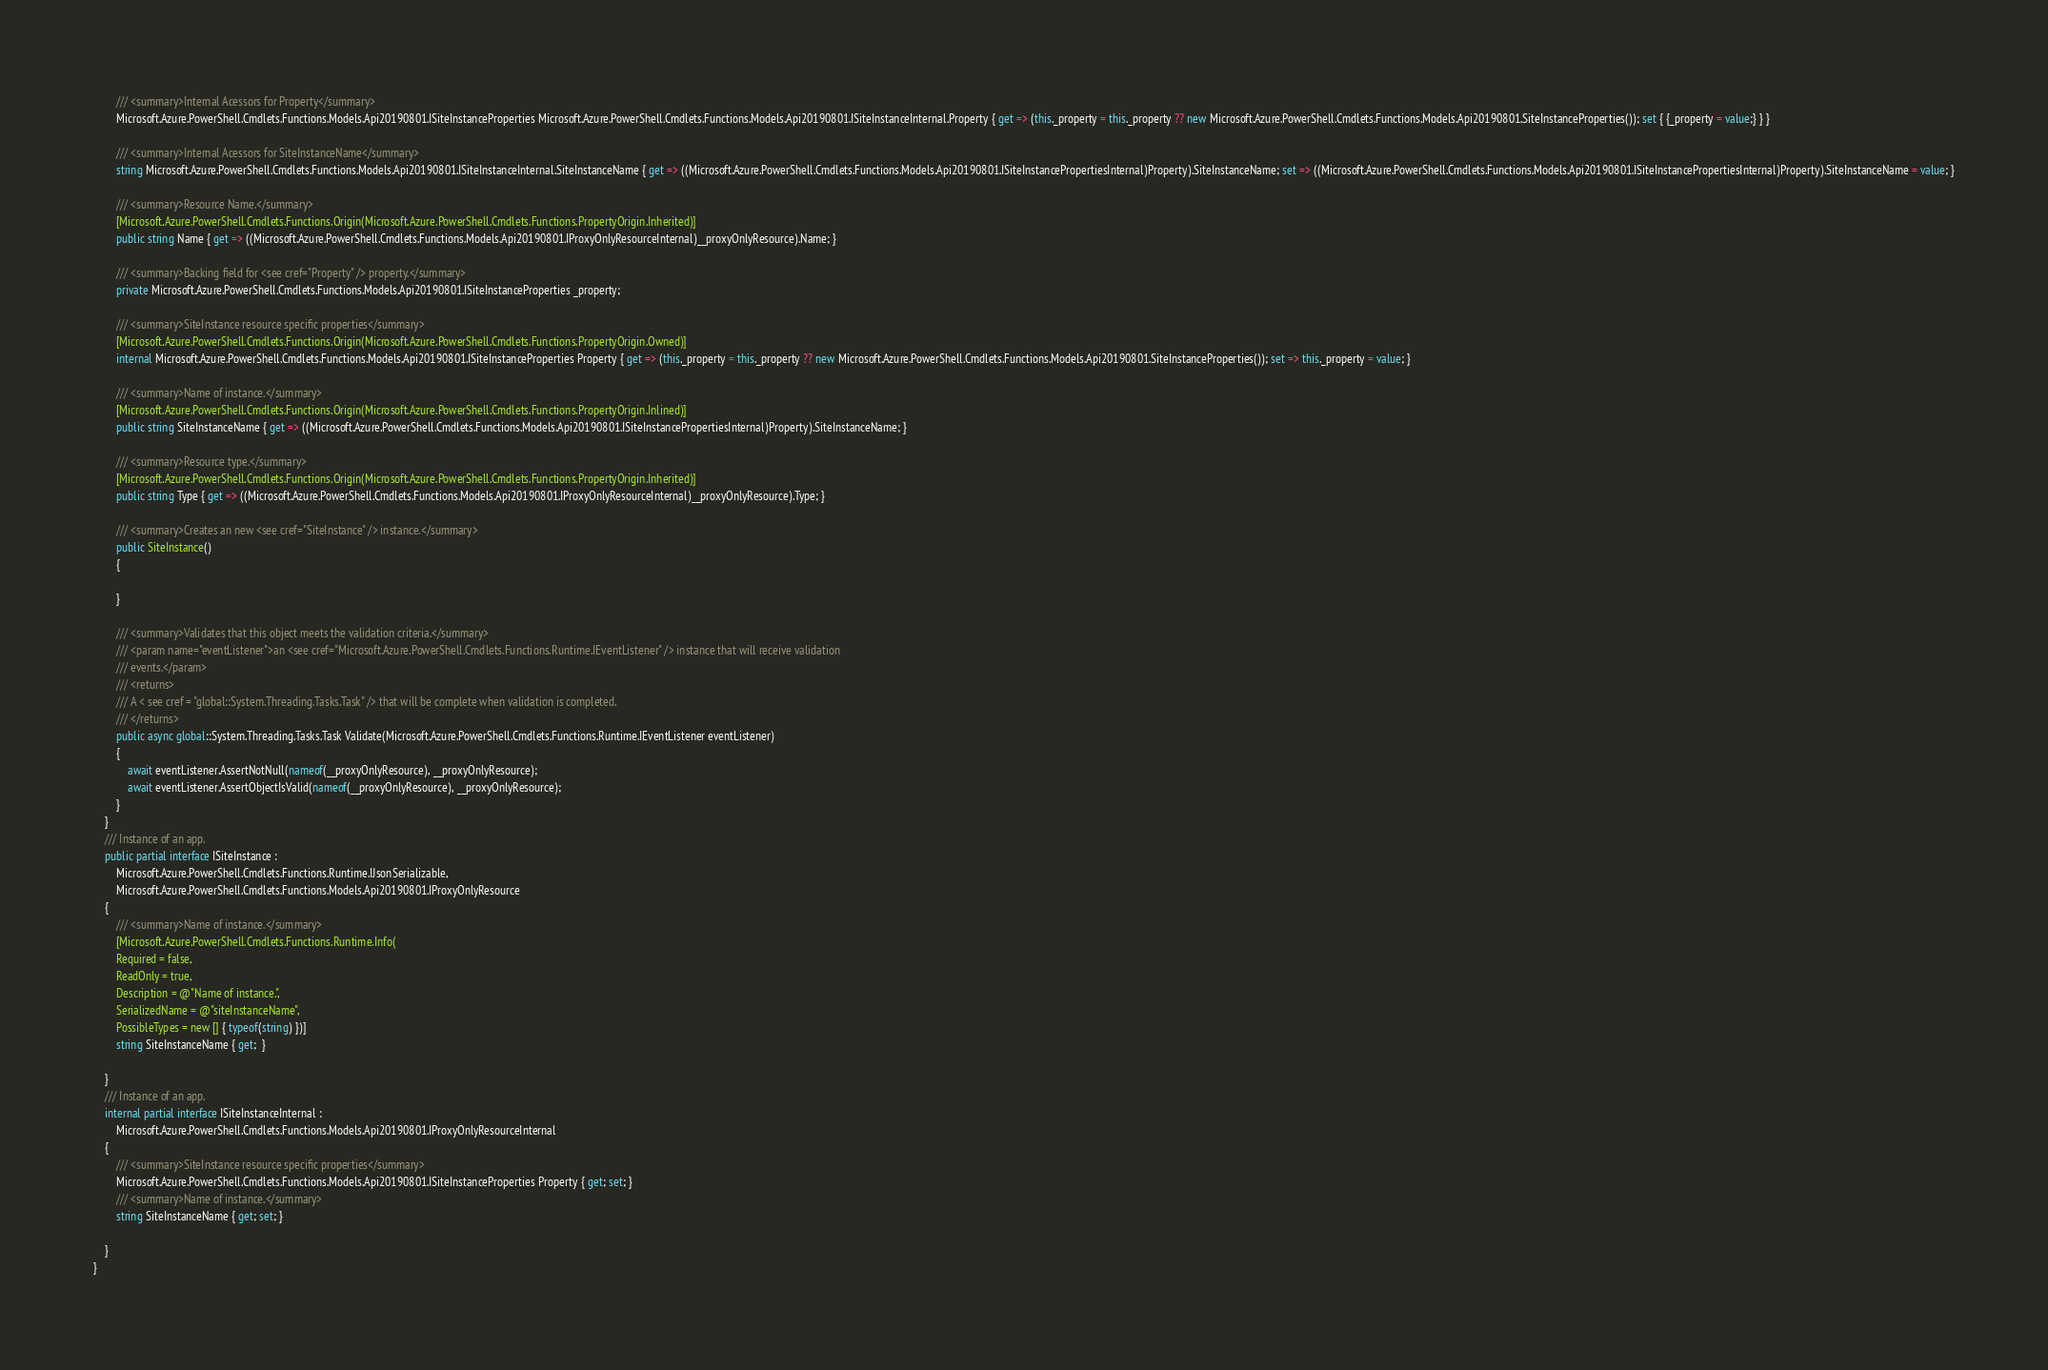Convert code to text. <code><loc_0><loc_0><loc_500><loc_500><_C#_>        /// <summary>Internal Acessors for Property</summary>
        Microsoft.Azure.PowerShell.Cmdlets.Functions.Models.Api20190801.ISiteInstanceProperties Microsoft.Azure.PowerShell.Cmdlets.Functions.Models.Api20190801.ISiteInstanceInternal.Property { get => (this._property = this._property ?? new Microsoft.Azure.PowerShell.Cmdlets.Functions.Models.Api20190801.SiteInstanceProperties()); set { {_property = value;} } }

        /// <summary>Internal Acessors for SiteInstanceName</summary>
        string Microsoft.Azure.PowerShell.Cmdlets.Functions.Models.Api20190801.ISiteInstanceInternal.SiteInstanceName { get => ((Microsoft.Azure.PowerShell.Cmdlets.Functions.Models.Api20190801.ISiteInstancePropertiesInternal)Property).SiteInstanceName; set => ((Microsoft.Azure.PowerShell.Cmdlets.Functions.Models.Api20190801.ISiteInstancePropertiesInternal)Property).SiteInstanceName = value; }

        /// <summary>Resource Name.</summary>
        [Microsoft.Azure.PowerShell.Cmdlets.Functions.Origin(Microsoft.Azure.PowerShell.Cmdlets.Functions.PropertyOrigin.Inherited)]
        public string Name { get => ((Microsoft.Azure.PowerShell.Cmdlets.Functions.Models.Api20190801.IProxyOnlyResourceInternal)__proxyOnlyResource).Name; }

        /// <summary>Backing field for <see cref="Property" /> property.</summary>
        private Microsoft.Azure.PowerShell.Cmdlets.Functions.Models.Api20190801.ISiteInstanceProperties _property;

        /// <summary>SiteInstance resource specific properties</summary>
        [Microsoft.Azure.PowerShell.Cmdlets.Functions.Origin(Microsoft.Azure.PowerShell.Cmdlets.Functions.PropertyOrigin.Owned)]
        internal Microsoft.Azure.PowerShell.Cmdlets.Functions.Models.Api20190801.ISiteInstanceProperties Property { get => (this._property = this._property ?? new Microsoft.Azure.PowerShell.Cmdlets.Functions.Models.Api20190801.SiteInstanceProperties()); set => this._property = value; }

        /// <summary>Name of instance.</summary>
        [Microsoft.Azure.PowerShell.Cmdlets.Functions.Origin(Microsoft.Azure.PowerShell.Cmdlets.Functions.PropertyOrigin.Inlined)]
        public string SiteInstanceName { get => ((Microsoft.Azure.PowerShell.Cmdlets.Functions.Models.Api20190801.ISiteInstancePropertiesInternal)Property).SiteInstanceName; }

        /// <summary>Resource type.</summary>
        [Microsoft.Azure.PowerShell.Cmdlets.Functions.Origin(Microsoft.Azure.PowerShell.Cmdlets.Functions.PropertyOrigin.Inherited)]
        public string Type { get => ((Microsoft.Azure.PowerShell.Cmdlets.Functions.Models.Api20190801.IProxyOnlyResourceInternal)__proxyOnlyResource).Type; }

        /// <summary>Creates an new <see cref="SiteInstance" /> instance.</summary>
        public SiteInstance()
        {

        }

        /// <summary>Validates that this object meets the validation criteria.</summary>
        /// <param name="eventListener">an <see cref="Microsoft.Azure.PowerShell.Cmdlets.Functions.Runtime.IEventListener" /> instance that will receive validation
        /// events.</param>
        /// <returns>
        /// A < see cref = "global::System.Threading.Tasks.Task" /> that will be complete when validation is completed.
        /// </returns>
        public async global::System.Threading.Tasks.Task Validate(Microsoft.Azure.PowerShell.Cmdlets.Functions.Runtime.IEventListener eventListener)
        {
            await eventListener.AssertNotNull(nameof(__proxyOnlyResource), __proxyOnlyResource);
            await eventListener.AssertObjectIsValid(nameof(__proxyOnlyResource), __proxyOnlyResource);
        }
    }
    /// Instance of an app.
    public partial interface ISiteInstance :
        Microsoft.Azure.PowerShell.Cmdlets.Functions.Runtime.IJsonSerializable,
        Microsoft.Azure.PowerShell.Cmdlets.Functions.Models.Api20190801.IProxyOnlyResource
    {
        /// <summary>Name of instance.</summary>
        [Microsoft.Azure.PowerShell.Cmdlets.Functions.Runtime.Info(
        Required = false,
        ReadOnly = true,
        Description = @"Name of instance.",
        SerializedName = @"siteInstanceName",
        PossibleTypes = new [] { typeof(string) })]
        string SiteInstanceName { get;  }

    }
    /// Instance of an app.
    internal partial interface ISiteInstanceInternal :
        Microsoft.Azure.PowerShell.Cmdlets.Functions.Models.Api20190801.IProxyOnlyResourceInternal
    {
        /// <summary>SiteInstance resource specific properties</summary>
        Microsoft.Azure.PowerShell.Cmdlets.Functions.Models.Api20190801.ISiteInstanceProperties Property { get; set; }
        /// <summary>Name of instance.</summary>
        string SiteInstanceName { get; set; }

    }
}</code> 